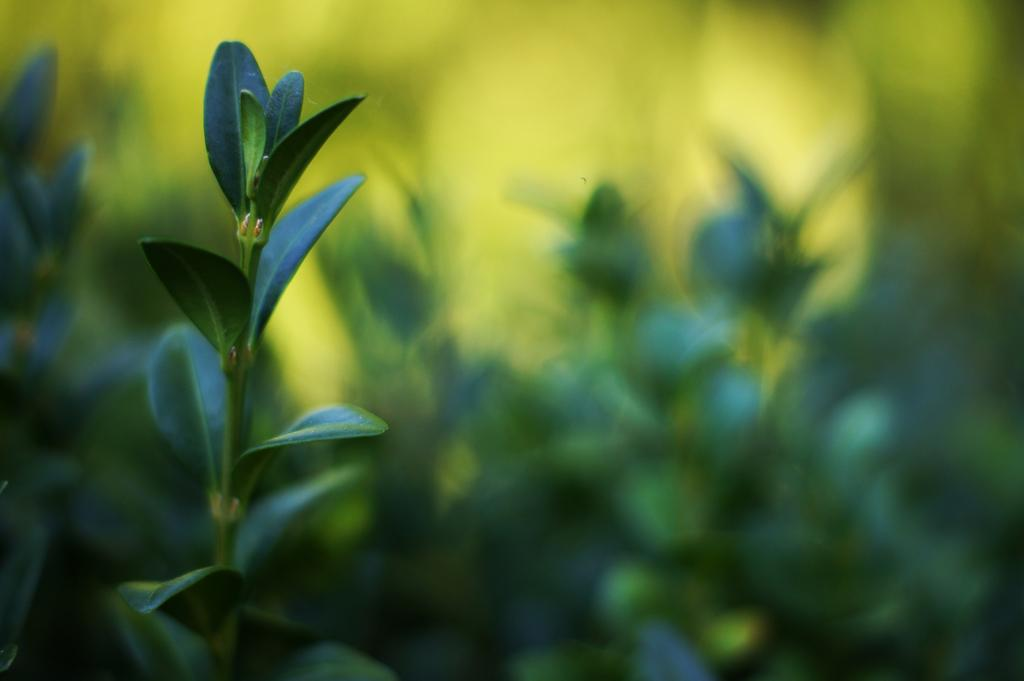What type of living organisms can be seen in the image? Plants can be seen in the image. What is the color of the plants in the image? The plants are green in color. What is the color of the background in the image? The background of the image is green in color. What type of behavior is exhibited by the quilt in the image? There is no quilt present in the image, so it is not possible to determine any behavior. 